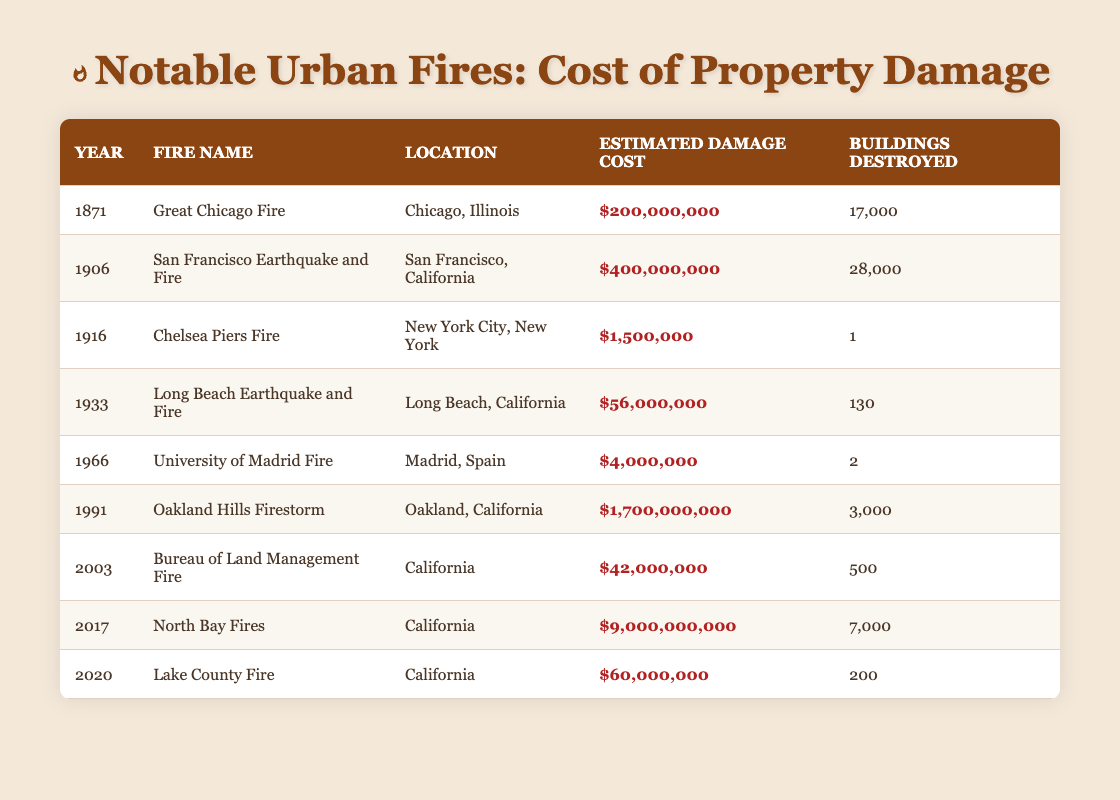What was the estimated damage cost of the Great Chicago Fire? The table shows that the estimated damage cost for the Great Chicago Fire in 1871 is listed as $200,000,000.
Answer: $200,000,000 How many buildings were destroyed in the San Francisco Earthquake and Fire? The data for the San Francisco Earthquake and Fire in 1906 indicates that 28,000 buildings were destroyed.
Answer: 28,000 Which fire had the highest estimated damage cost, and what was that cost? According to the table, the North Bay Fires in 2017 had the highest estimated damage cost at $9,000,000,000.
Answer: North Bay Fires; $9,000,000,000 What is the total number of buildings destroyed in the two fires with the highest estimated damage cost? The two fires with the highest estimated damage costs are the North Bay Fires (7,000 buildings) and the Oakland Hills Firestorm (3,000 buildings). Adding these numbers gives 7,000 + 3,000 = 10,000 buildings destroyed.
Answer: 10,000 Is it true that the University of Madrid Fire caused more damage than the Chelsea Piers Fire? By comparing the estimated damage costs, the University of Madrid Fire (approximately $4,000,000) caused less damage than the Chelsea Piers Fire (approximately $1,500,000). Therefore, the statement is false.
Answer: No What was the average estimated damage cost of the fires that occurred in the 21st century? The fires in the 21st century listed are the Oakland Hills Firestorm ($1,700,000,000), the Bureau of Land Management Fire ($42,000,000), the North Bay Fires ($9,000,000,000), and the Lake County Fire ($60,000,000). The sum of these costs is $1,700,000,000 + $42,000,000 + $9,000,000,000 + $60,000,000 = $10,802,000,000. There are 4 data points, so the average is $10,802,000,000 / 4 = $2,700,500,000.
Answer: $2,700,500,000 Which fire had the lowest damage cost, and what was that cost? From the table, the Chelsea Piers Fire in 1916 had the lowest damage cost at $1,500,000.
Answer: Chelsea Piers Fire; $1,500,000 How many fires listed caused damage over $100 million? The fires that caused damage over $100 million are the Great Chicago Fire, San Francisco Earthquake and Fire, Oakland Hills Firestorm, and North Bay Fires. There are 4 such fires listed.
Answer: 4 